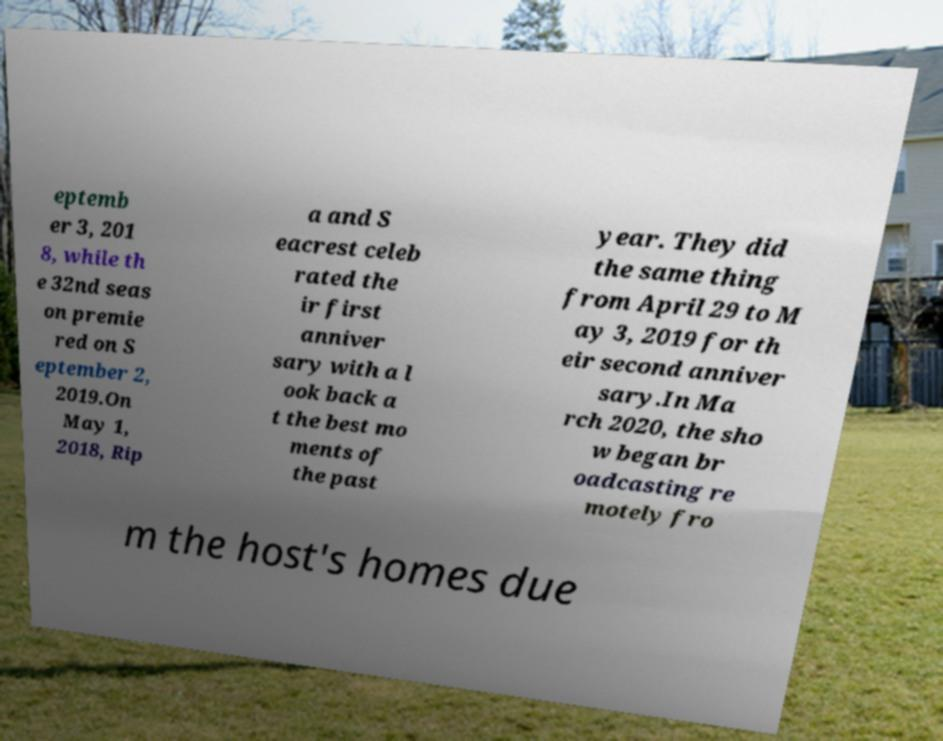There's text embedded in this image that I need extracted. Can you transcribe it verbatim? eptemb er 3, 201 8, while th e 32nd seas on premie red on S eptember 2, 2019.On May 1, 2018, Rip a and S eacrest celeb rated the ir first anniver sary with a l ook back a t the best mo ments of the past year. They did the same thing from April 29 to M ay 3, 2019 for th eir second anniver sary.In Ma rch 2020, the sho w began br oadcasting re motely fro m the host's homes due 